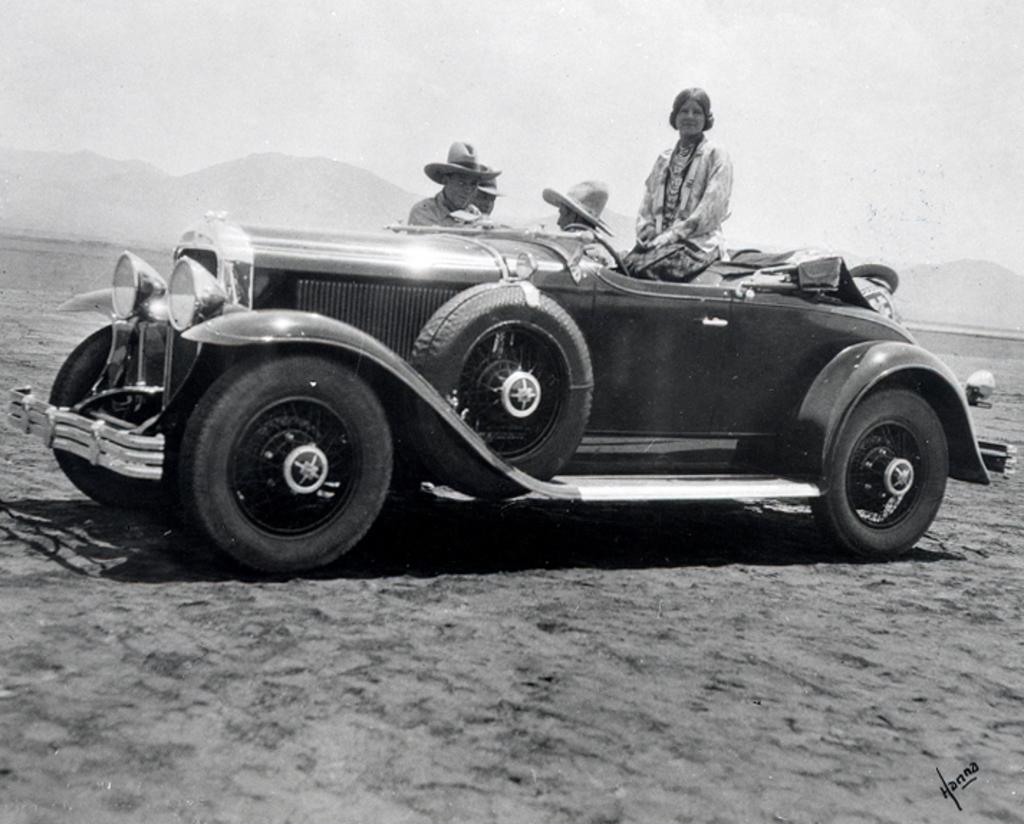What are the people in the image doing? There are persons sitting in a vehicle in the image. What can be seen in the background of the image? There is a sky and a hill visible in the background of the image. What type of sign can be seen on the hill in the image? There is no sign present on the hill in the image. What kind of pump is visible near the vehicle in the image? There is no pump visible near the vehicle in the image. 